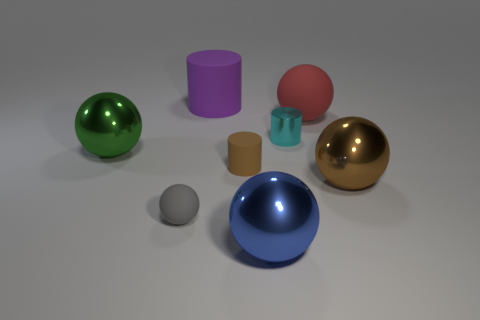There is a ball that is both in front of the brown ball and right of the small ball; what material is it made of?
Offer a terse response. Metal. There is a shiny thing that is behind the shiny ball that is behind the big shiny object that is right of the cyan metal thing; what shape is it?
Offer a very short reply. Cylinder. How many cylinders are large green shiny objects or brown matte things?
Your response must be concise. 1. There is a big metal object to the right of the blue metal thing; does it have the same color as the big matte cylinder?
Your answer should be compact. No. What material is the small cyan thing in front of the purple cylinder left of the large metallic sphere to the right of the red rubber thing?
Your answer should be compact. Metal. Does the brown cylinder have the same size as the metallic cylinder?
Keep it short and to the point. Yes. There is a big matte cylinder; does it have the same color as the matte cylinder that is in front of the big red object?
Provide a short and direct response. No. What is the shape of the brown object that is made of the same material as the red sphere?
Your response must be concise. Cylinder. There is a small brown thing in front of the small cyan shiny object; is its shape the same as the tiny cyan metallic thing?
Make the answer very short. Yes. What is the size of the metallic ball that is left of the rubber object to the left of the big purple cylinder?
Your response must be concise. Large. 